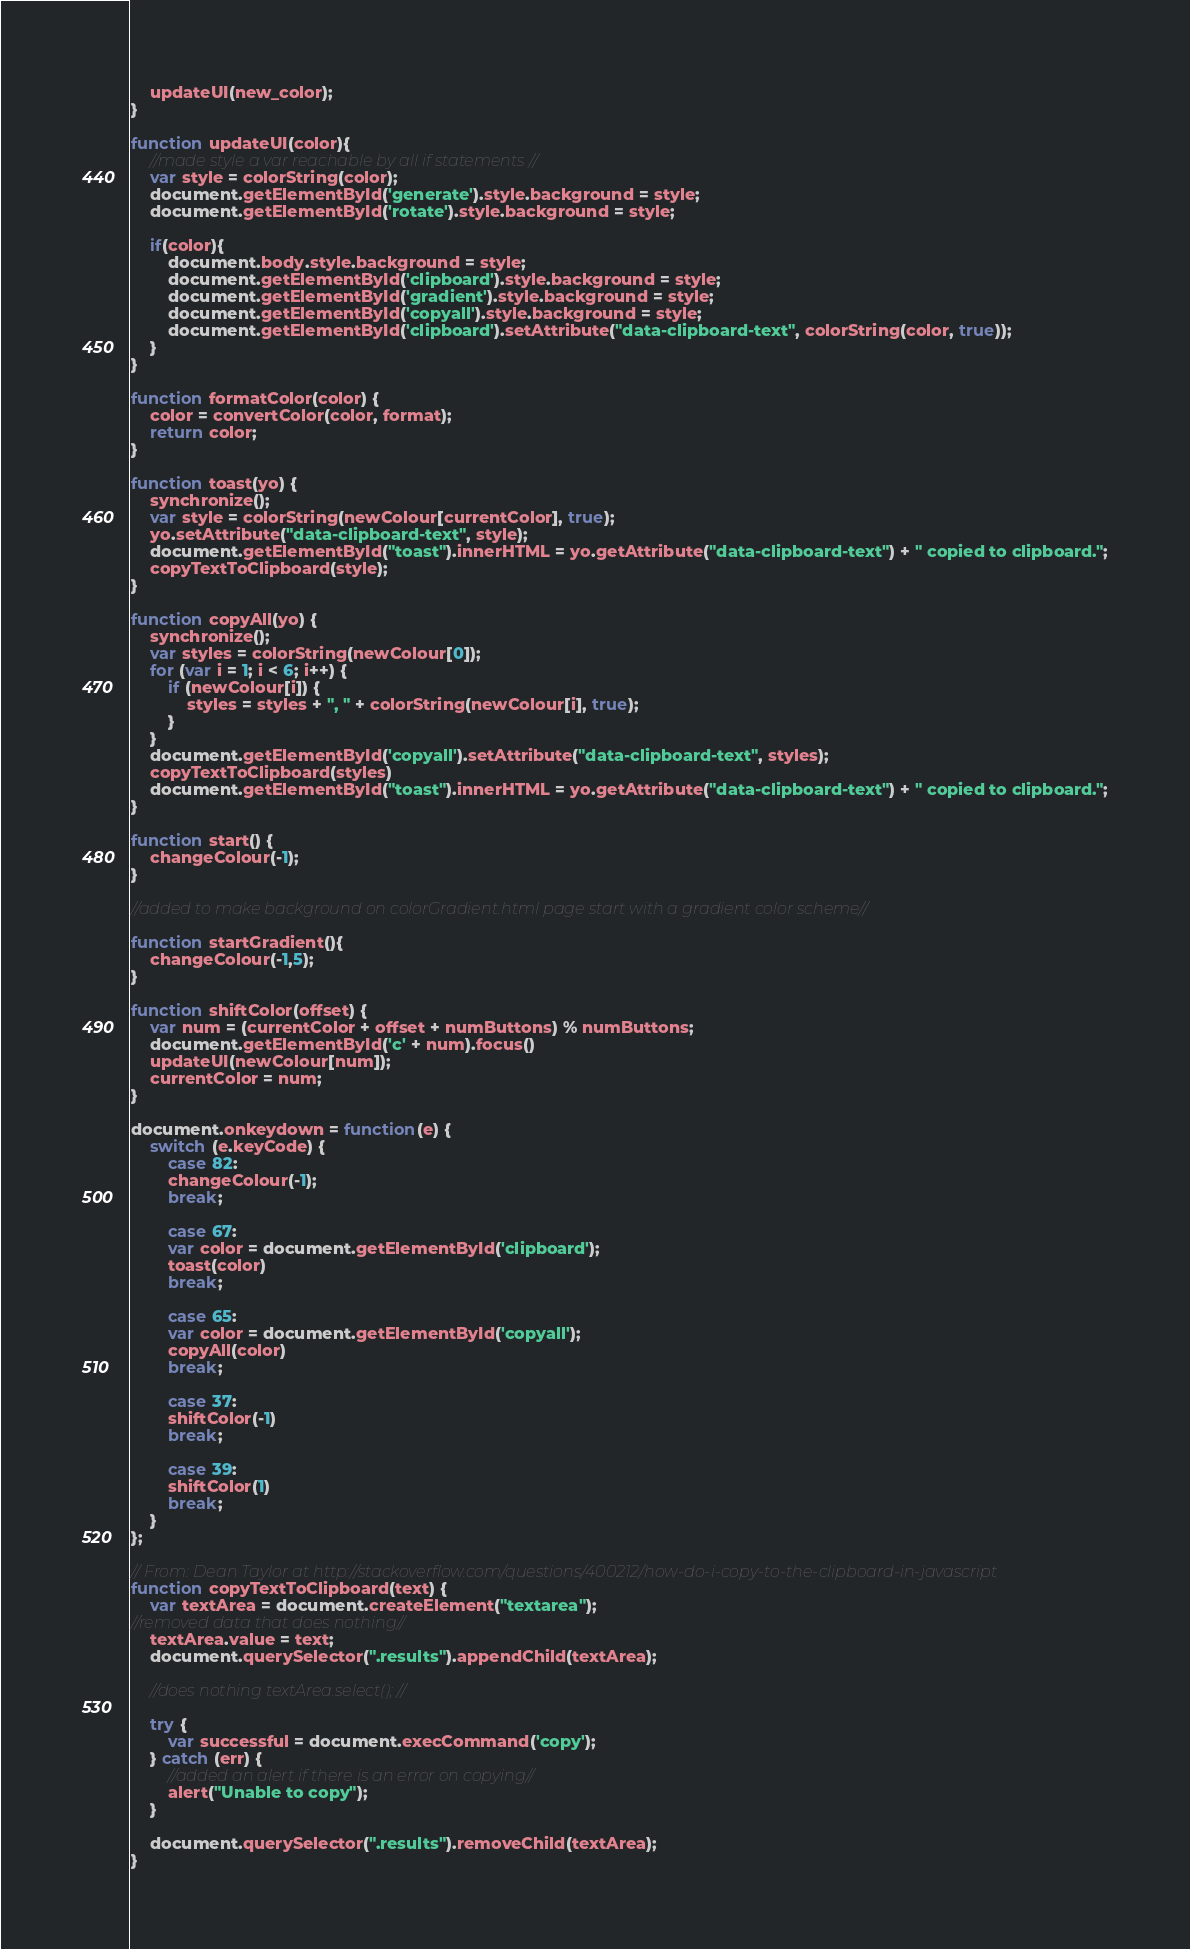Convert code to text. <code><loc_0><loc_0><loc_500><loc_500><_JavaScript_>    updateUI(new_color);
}

function updateUI(color){
	//made style a var reachable by all if statements //
    var style = colorString(color);
    document.getElementById('generate').style.background = style;
    document.getElementById('rotate').style.background = style;

    if(color){
        document.body.style.background = style;
        document.getElementById('clipboard').style.background = style;
        document.getElementById('gradient').style.background = style;
        document.getElementById('copyall').style.background = style;
        document.getElementById('clipboard').setAttribute("data-clipboard-text", colorString(color, true));
    }
}

function formatColor(color) {
    color = convertColor(color, format);
    return color;
}

function toast(yo) {
    synchronize();
    var style = colorString(newColour[currentColor], true);
    yo.setAttribute("data-clipboard-text", style);
    document.getElementById("toast").innerHTML = yo.getAttribute("data-clipboard-text") + " copied to clipboard.";
    copyTextToClipboard(style);
}

function copyAll(yo) {
    synchronize();
    var styles = colorString(newColour[0]);
    for (var i = 1; i < 6; i++) {
        if (newColour[i]) {
            styles = styles + ", " + colorString(newColour[i], true);
        }
    }
    document.getElementById('copyall').setAttribute("data-clipboard-text", styles);
    copyTextToClipboard(styles)
    document.getElementById("toast").innerHTML = yo.getAttribute("data-clipboard-text") + " copied to clipboard.";
}

function start() {
    changeColour(-1);
}

//added to make background on colorGradient.html page start with a gradient color scheme//

function startGradient(){
	changeColour(-1,5);
}

function shiftColor(offset) {
    var num = (currentColor + offset + numButtons) % numButtons;
    document.getElementById('c' + num).focus()
    updateUI(newColour[num]);
    currentColor = num;
}

document.onkeydown = function(e) {
    switch (e.keyCode) {
        case 82:
        changeColour(-1);
        break;

        case 67:
        var color = document.getElementById('clipboard');
        toast(color)
        break;

        case 65:
        var color = document.getElementById('copyall');
        copyAll(color)
        break;

        case 37:
        shiftColor(-1)
        break;

        case 39:
        shiftColor(1)
        break;
    }
};

// From: Dean Taylor at http://stackoverflow.com/questions/400212/how-do-i-copy-to-the-clipboard-in-javascript
function copyTextToClipboard(text) {
    var textArea = document.createElement("textarea");
//removed data that does nothing//
    textArea.value = text;
    document.querySelector(".results").appendChild(textArea);

    //does nothing textArea.select(); //

    try {
        var successful = document.execCommand('copy');
    } catch (err) {
		//added an alert if there is an error on copying//
		alert("Unable to copy");
    }

    document.querySelector(".results").removeChild(textArea);
}
</code> 